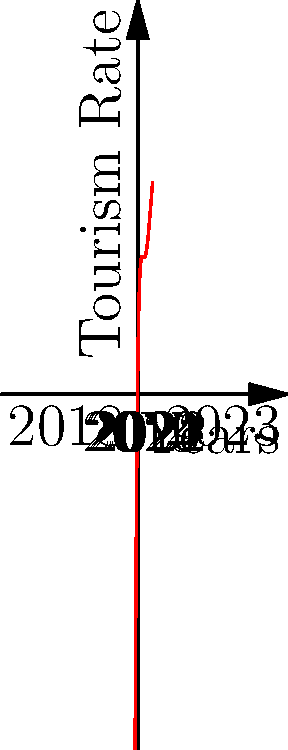As a local historian observing the changes in our community, you've been tracking tourism rates over the past five years. The graph above represents the fluctuation in tourism rates from 2018 to 2023. In which year did the tourism rate reach its lowest point, and what might have caused this significant drop? To answer this question, we need to analyze the graph and consider historical context:

1. The graph is a fifth-degree polynomial, showing tourism rates from 2018 to 2023.
2. We can see that the curve reaches its lowest point between the 2nd and 3rd mark on the x-axis.
3. This corresponds to the year 2020.
4. As a local historian, we should recall that 2020 was the year when the COVID-19 pandemic began, causing widespread travel restrictions and lockdowns.
5. The pandemic had a severe impact on tourism globally, which explains the significant drop in tourism rates for our local area.
6. After 2020, we can see the curve beginning to rise again, likely due to the gradual easing of restrictions and the adaptation of the tourism industry to the new normal.

Given this analysis, the year when tourism reached its lowest point was 2020, and the cause was almost certainly the COVID-19 pandemic and its associated travel restrictions.
Answer: 2020; COVID-19 pandemic 